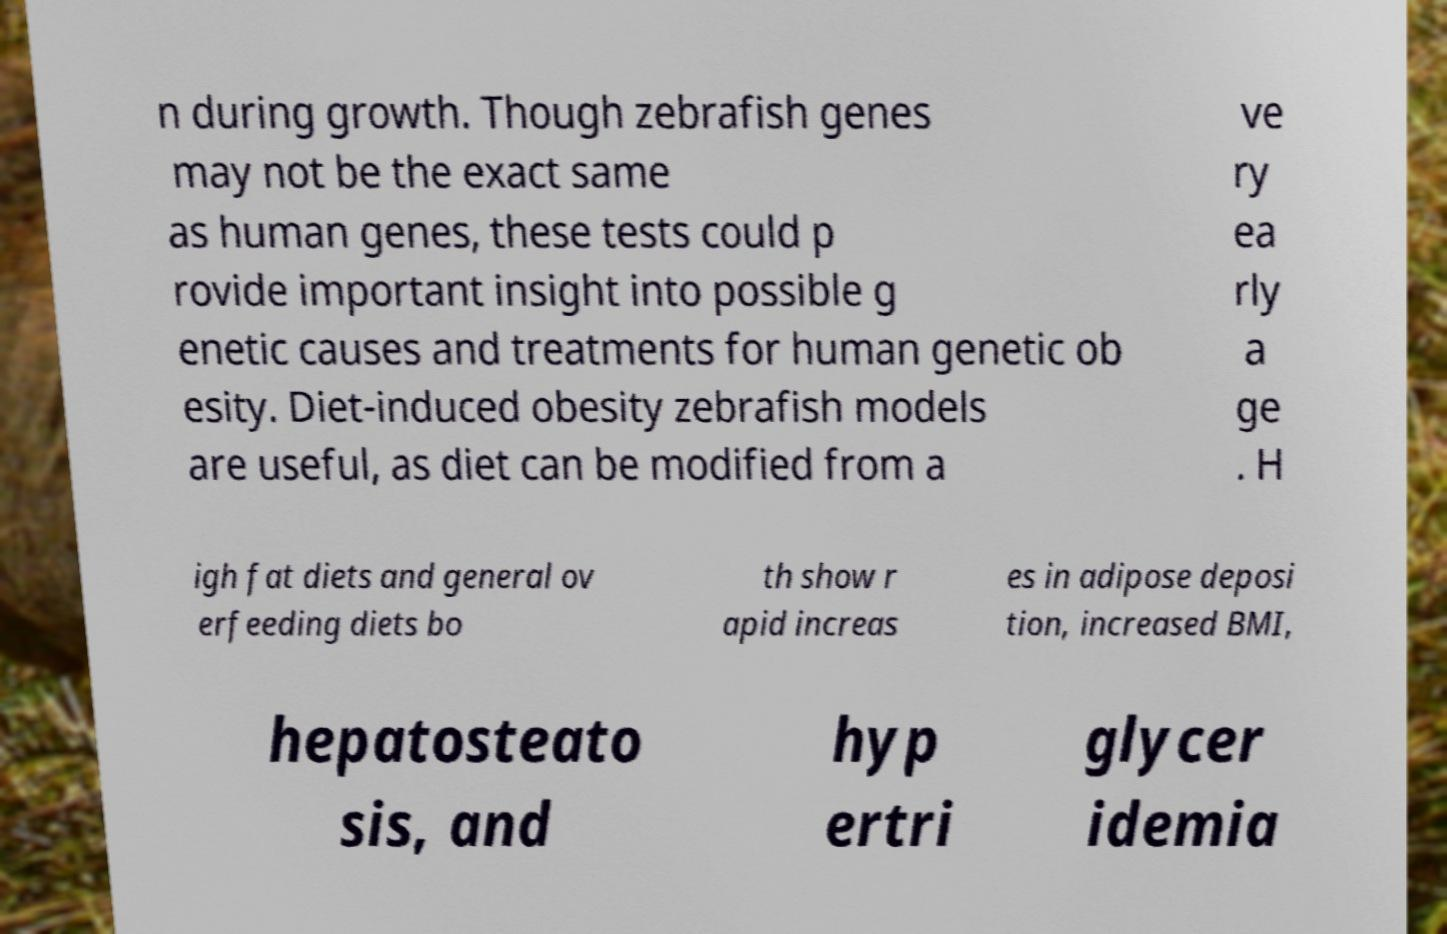Could you assist in decoding the text presented in this image and type it out clearly? n during growth. Though zebrafish genes may not be the exact same as human genes, these tests could p rovide important insight into possible g enetic causes and treatments for human genetic ob esity. Diet-induced obesity zebrafish models are useful, as diet can be modified from a ve ry ea rly a ge . H igh fat diets and general ov erfeeding diets bo th show r apid increas es in adipose deposi tion, increased BMI, hepatosteato sis, and hyp ertri glycer idemia 